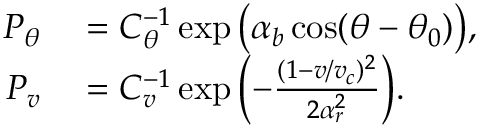Convert formula to latex. <formula><loc_0><loc_0><loc_500><loc_500>\begin{array} { r l } { P _ { \theta } } & = C _ { \theta } ^ { - 1 } \exp { \left ( \alpha _ { b } \cos ( \theta - \theta _ { 0 } ) \right ) } , } \\ { P _ { v } } & = C _ { v } ^ { - 1 } \exp { \left ( - \frac { ( 1 - v / v _ { c } ) ^ { 2 } } { 2 \alpha _ { r } ^ { 2 } } \right ) } . } \end{array}</formula> 